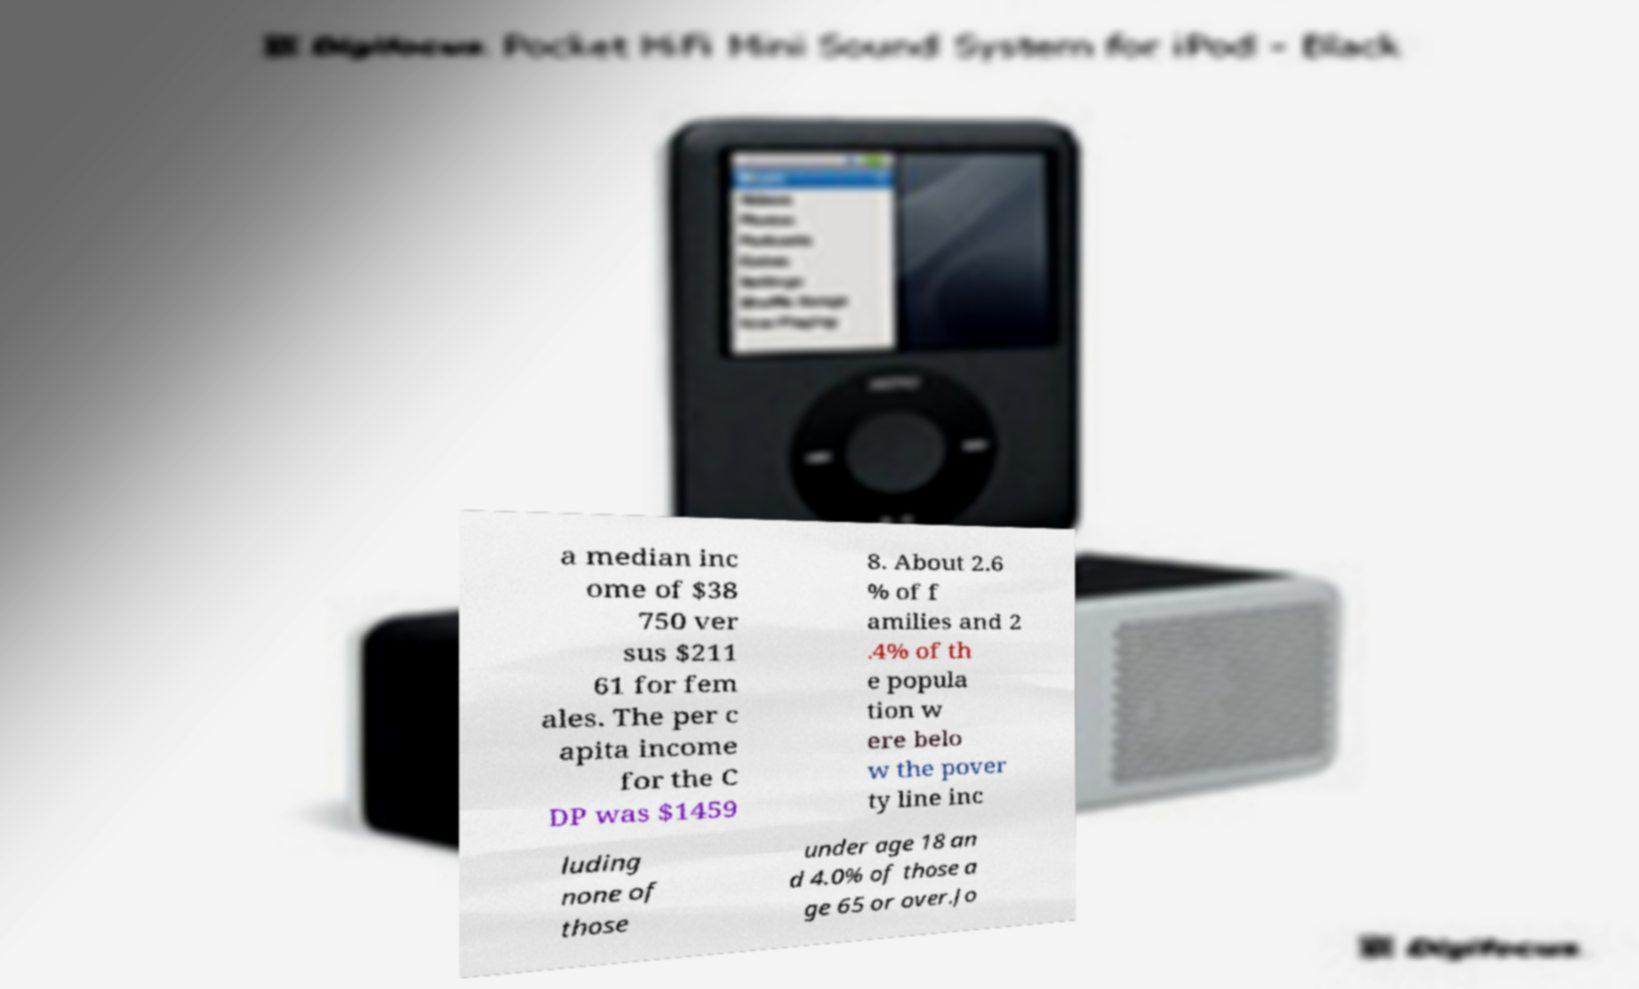Please read and relay the text visible in this image. What does it say? a median inc ome of $38 750 ver sus $211 61 for fem ales. The per c apita income for the C DP was $1459 8. About 2.6 % of f amilies and 2 .4% of th e popula tion w ere belo w the pover ty line inc luding none of those under age 18 an d 4.0% of those a ge 65 or over.Jo 